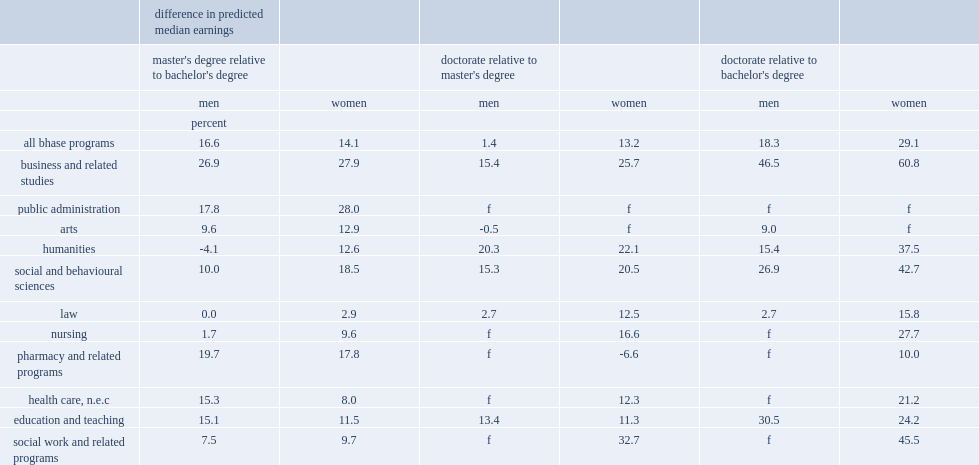How much did women with a master's degree in business and related studies earned more than those with a bachelor's degree in the same field? 27.9. How much did men with a master's degree in business and related studies earned more than those with a bachelor's degree in the same field? 26.9. 